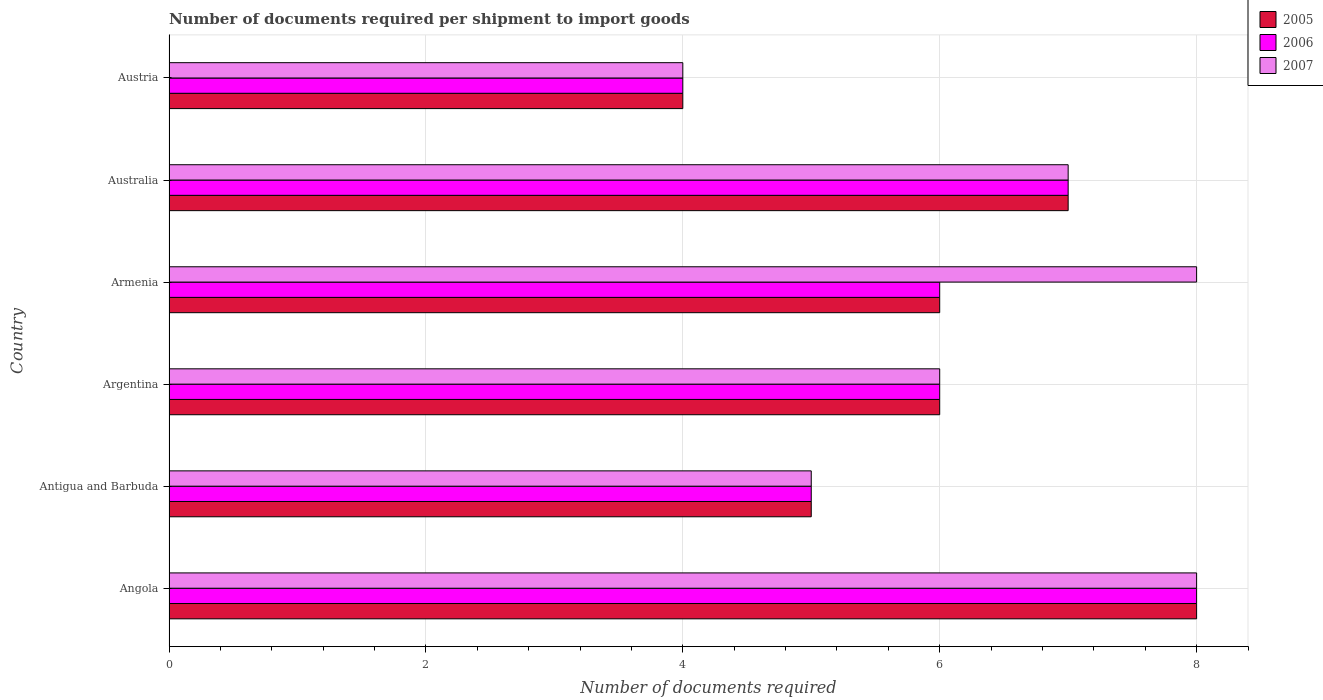Are the number of bars per tick equal to the number of legend labels?
Provide a succinct answer. Yes. How many bars are there on the 3rd tick from the top?
Your response must be concise. 3. What is the number of documents required per shipment to import goods in 2005 in Australia?
Offer a very short reply. 7. Across all countries, what is the maximum number of documents required per shipment to import goods in 2007?
Ensure brevity in your answer.  8. In which country was the number of documents required per shipment to import goods in 2007 maximum?
Your answer should be compact. Angola. In which country was the number of documents required per shipment to import goods in 2006 minimum?
Make the answer very short. Austria. What is the difference between the number of documents required per shipment to import goods in 2005 in Armenia and the number of documents required per shipment to import goods in 2007 in Angola?
Offer a very short reply. -2. What is the average number of documents required per shipment to import goods in 2007 per country?
Your answer should be compact. 6.33. What is the difference between the number of documents required per shipment to import goods in 2006 and number of documents required per shipment to import goods in 2005 in Armenia?
Offer a very short reply. 0. What is the ratio of the number of documents required per shipment to import goods in 2005 in Argentina to that in Austria?
Provide a short and direct response. 1.5. Is the difference between the number of documents required per shipment to import goods in 2006 in Australia and Austria greater than the difference between the number of documents required per shipment to import goods in 2005 in Australia and Austria?
Provide a succinct answer. No. Is the sum of the number of documents required per shipment to import goods in 2007 in Angola and Argentina greater than the maximum number of documents required per shipment to import goods in 2005 across all countries?
Your answer should be very brief. Yes. What does the 2nd bar from the top in Argentina represents?
Your answer should be compact. 2006. How many bars are there?
Your response must be concise. 18. What is the difference between two consecutive major ticks on the X-axis?
Make the answer very short. 2. Are the values on the major ticks of X-axis written in scientific E-notation?
Offer a terse response. No. Does the graph contain grids?
Your response must be concise. Yes. How are the legend labels stacked?
Provide a succinct answer. Vertical. What is the title of the graph?
Your answer should be compact. Number of documents required per shipment to import goods. What is the label or title of the X-axis?
Make the answer very short. Number of documents required. What is the label or title of the Y-axis?
Make the answer very short. Country. What is the Number of documents required of 2005 in Angola?
Your response must be concise. 8. What is the Number of documents required in 2006 in Angola?
Give a very brief answer. 8. What is the Number of documents required in 2006 in Antigua and Barbuda?
Your answer should be very brief. 5. What is the Number of documents required of 2007 in Antigua and Barbuda?
Make the answer very short. 5. What is the Number of documents required of 2007 in Argentina?
Offer a terse response. 6. What is the Number of documents required of 2006 in Armenia?
Your answer should be very brief. 6. What is the Number of documents required of 2006 in Australia?
Your answer should be compact. 7. What is the Number of documents required of 2007 in Australia?
Provide a succinct answer. 7. What is the Number of documents required in 2005 in Austria?
Your answer should be compact. 4. Across all countries, what is the minimum Number of documents required in 2005?
Provide a succinct answer. 4. Across all countries, what is the minimum Number of documents required of 2007?
Your answer should be very brief. 4. What is the total Number of documents required of 2005 in the graph?
Give a very brief answer. 36. What is the total Number of documents required in 2006 in the graph?
Offer a terse response. 36. What is the difference between the Number of documents required in 2005 in Angola and that in Antigua and Barbuda?
Offer a very short reply. 3. What is the difference between the Number of documents required of 2007 in Angola and that in Antigua and Barbuda?
Give a very brief answer. 3. What is the difference between the Number of documents required of 2005 in Angola and that in Argentina?
Provide a succinct answer. 2. What is the difference between the Number of documents required of 2007 in Angola and that in Argentina?
Offer a terse response. 2. What is the difference between the Number of documents required in 2005 in Angola and that in Armenia?
Provide a short and direct response. 2. What is the difference between the Number of documents required in 2006 in Angola and that in Armenia?
Ensure brevity in your answer.  2. What is the difference between the Number of documents required in 2005 in Angola and that in Australia?
Your answer should be very brief. 1. What is the difference between the Number of documents required in 2006 in Angola and that in Australia?
Keep it short and to the point. 1. What is the difference between the Number of documents required in 2005 in Angola and that in Austria?
Ensure brevity in your answer.  4. What is the difference between the Number of documents required in 2005 in Antigua and Barbuda and that in Argentina?
Your response must be concise. -1. What is the difference between the Number of documents required of 2007 in Antigua and Barbuda and that in Argentina?
Ensure brevity in your answer.  -1. What is the difference between the Number of documents required of 2006 in Antigua and Barbuda and that in Armenia?
Give a very brief answer. -1. What is the difference between the Number of documents required in 2007 in Antigua and Barbuda and that in Armenia?
Your answer should be very brief. -3. What is the difference between the Number of documents required in 2006 in Antigua and Barbuda and that in Australia?
Provide a short and direct response. -2. What is the difference between the Number of documents required in 2007 in Antigua and Barbuda and that in Australia?
Offer a very short reply. -2. What is the difference between the Number of documents required in 2006 in Antigua and Barbuda and that in Austria?
Offer a terse response. 1. What is the difference between the Number of documents required of 2007 in Antigua and Barbuda and that in Austria?
Keep it short and to the point. 1. What is the difference between the Number of documents required in 2006 in Argentina and that in Armenia?
Your response must be concise. 0. What is the difference between the Number of documents required of 2007 in Argentina and that in Armenia?
Make the answer very short. -2. What is the difference between the Number of documents required of 2005 in Argentina and that in Australia?
Provide a short and direct response. -1. What is the difference between the Number of documents required of 2006 in Argentina and that in Australia?
Your answer should be compact. -1. What is the difference between the Number of documents required of 2005 in Argentina and that in Austria?
Your answer should be compact. 2. What is the difference between the Number of documents required in 2006 in Argentina and that in Austria?
Your answer should be very brief. 2. What is the difference between the Number of documents required of 2006 in Armenia and that in Australia?
Your answer should be compact. -1. What is the difference between the Number of documents required of 2007 in Armenia and that in Australia?
Provide a succinct answer. 1. What is the difference between the Number of documents required of 2007 in Armenia and that in Austria?
Your response must be concise. 4. What is the difference between the Number of documents required of 2005 in Australia and that in Austria?
Your answer should be very brief. 3. What is the difference between the Number of documents required in 2006 in Australia and that in Austria?
Your answer should be compact. 3. What is the difference between the Number of documents required of 2007 in Australia and that in Austria?
Your answer should be compact. 3. What is the difference between the Number of documents required in 2005 in Angola and the Number of documents required in 2006 in Antigua and Barbuda?
Your response must be concise. 3. What is the difference between the Number of documents required in 2005 in Angola and the Number of documents required in 2007 in Antigua and Barbuda?
Give a very brief answer. 3. What is the difference between the Number of documents required of 2005 in Angola and the Number of documents required of 2006 in Argentina?
Provide a succinct answer. 2. What is the difference between the Number of documents required in 2005 in Angola and the Number of documents required in 2007 in Australia?
Provide a short and direct response. 1. What is the difference between the Number of documents required in 2006 in Angola and the Number of documents required in 2007 in Austria?
Offer a very short reply. 4. What is the difference between the Number of documents required in 2005 in Antigua and Barbuda and the Number of documents required in 2007 in Armenia?
Offer a terse response. -3. What is the difference between the Number of documents required of 2005 in Antigua and Barbuda and the Number of documents required of 2006 in Australia?
Keep it short and to the point. -2. What is the difference between the Number of documents required in 2005 in Antigua and Barbuda and the Number of documents required in 2007 in Austria?
Keep it short and to the point. 1. What is the difference between the Number of documents required in 2006 in Antigua and Barbuda and the Number of documents required in 2007 in Austria?
Give a very brief answer. 1. What is the difference between the Number of documents required in 2005 in Argentina and the Number of documents required in 2006 in Australia?
Keep it short and to the point. -1. What is the difference between the Number of documents required in 2005 in Argentina and the Number of documents required in 2006 in Austria?
Offer a very short reply. 2. What is the difference between the Number of documents required of 2005 in Armenia and the Number of documents required of 2006 in Australia?
Offer a terse response. -1. What is the difference between the Number of documents required in 2006 in Armenia and the Number of documents required in 2007 in Australia?
Your answer should be very brief. -1. What is the difference between the Number of documents required of 2005 in Armenia and the Number of documents required of 2007 in Austria?
Your answer should be compact. 2. What is the average Number of documents required in 2006 per country?
Make the answer very short. 6. What is the average Number of documents required of 2007 per country?
Your response must be concise. 6.33. What is the difference between the Number of documents required in 2005 and Number of documents required in 2006 in Angola?
Keep it short and to the point. 0. What is the difference between the Number of documents required in 2006 and Number of documents required in 2007 in Angola?
Your answer should be very brief. 0. What is the difference between the Number of documents required in 2006 and Number of documents required in 2007 in Antigua and Barbuda?
Keep it short and to the point. 0. What is the difference between the Number of documents required in 2005 and Number of documents required in 2006 in Argentina?
Offer a terse response. 0. What is the difference between the Number of documents required in 2005 and Number of documents required in 2007 in Argentina?
Your response must be concise. 0. What is the difference between the Number of documents required in 2006 and Number of documents required in 2007 in Argentina?
Your response must be concise. 0. What is the difference between the Number of documents required of 2005 and Number of documents required of 2006 in Armenia?
Make the answer very short. 0. What is the difference between the Number of documents required of 2005 and Number of documents required of 2007 in Armenia?
Provide a short and direct response. -2. What is the difference between the Number of documents required in 2005 and Number of documents required in 2007 in Australia?
Provide a succinct answer. 0. What is the difference between the Number of documents required in 2006 and Number of documents required in 2007 in Australia?
Provide a short and direct response. 0. What is the difference between the Number of documents required of 2005 and Number of documents required of 2006 in Austria?
Provide a succinct answer. 0. What is the ratio of the Number of documents required in 2006 in Angola to that in Antigua and Barbuda?
Ensure brevity in your answer.  1.6. What is the ratio of the Number of documents required of 2007 in Angola to that in Argentina?
Keep it short and to the point. 1.33. What is the ratio of the Number of documents required in 2005 in Angola to that in Armenia?
Provide a succinct answer. 1.33. What is the ratio of the Number of documents required in 2007 in Angola to that in Armenia?
Ensure brevity in your answer.  1. What is the ratio of the Number of documents required in 2005 in Angola to that in Australia?
Your answer should be compact. 1.14. What is the ratio of the Number of documents required in 2007 in Angola to that in Austria?
Ensure brevity in your answer.  2. What is the ratio of the Number of documents required in 2005 in Antigua and Barbuda to that in Argentina?
Provide a short and direct response. 0.83. What is the ratio of the Number of documents required in 2006 in Antigua and Barbuda to that in Argentina?
Provide a short and direct response. 0.83. What is the ratio of the Number of documents required in 2007 in Antigua and Barbuda to that in Argentina?
Keep it short and to the point. 0.83. What is the ratio of the Number of documents required in 2007 in Antigua and Barbuda to that in Armenia?
Your response must be concise. 0.62. What is the ratio of the Number of documents required of 2005 in Antigua and Barbuda to that in Australia?
Ensure brevity in your answer.  0.71. What is the ratio of the Number of documents required of 2006 in Antigua and Barbuda to that in Australia?
Provide a short and direct response. 0.71. What is the ratio of the Number of documents required in 2007 in Antigua and Barbuda to that in Australia?
Offer a very short reply. 0.71. What is the ratio of the Number of documents required of 2005 in Antigua and Barbuda to that in Austria?
Your answer should be very brief. 1.25. What is the ratio of the Number of documents required in 2007 in Antigua and Barbuda to that in Austria?
Provide a succinct answer. 1.25. What is the ratio of the Number of documents required in 2007 in Argentina to that in Armenia?
Your response must be concise. 0.75. What is the ratio of the Number of documents required of 2005 in Argentina to that in Austria?
Your answer should be very brief. 1.5. What is the ratio of the Number of documents required of 2005 in Armenia to that in Australia?
Ensure brevity in your answer.  0.86. What is the ratio of the Number of documents required in 2006 in Armenia to that in Austria?
Your response must be concise. 1.5. What is the difference between the highest and the second highest Number of documents required in 2005?
Provide a short and direct response. 1. What is the difference between the highest and the second highest Number of documents required in 2006?
Keep it short and to the point. 1. What is the difference between the highest and the second highest Number of documents required in 2007?
Keep it short and to the point. 0. What is the difference between the highest and the lowest Number of documents required in 2005?
Offer a terse response. 4. What is the difference between the highest and the lowest Number of documents required in 2006?
Provide a succinct answer. 4. 